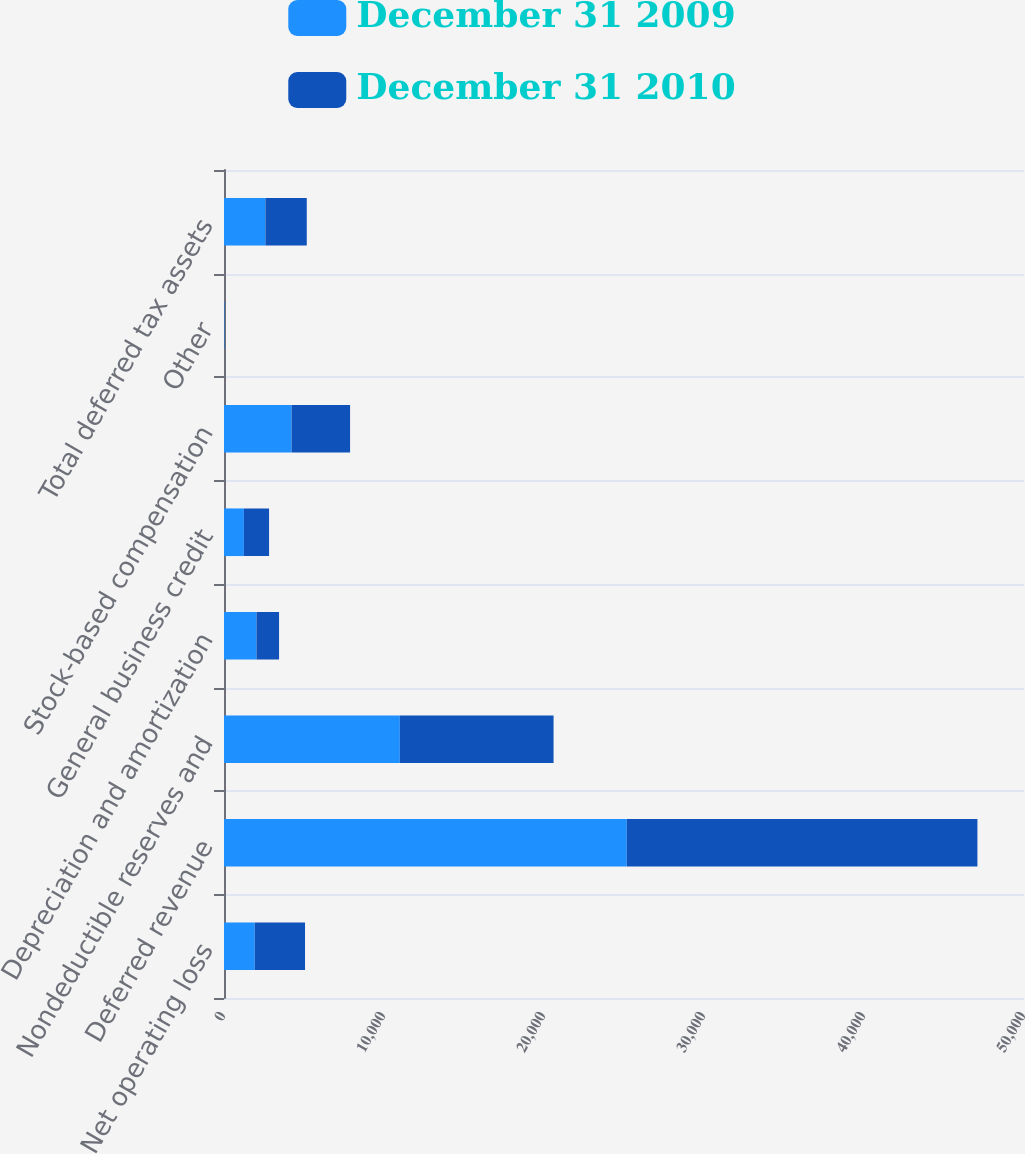Convert chart. <chart><loc_0><loc_0><loc_500><loc_500><stacked_bar_chart><ecel><fcel>Net operating loss<fcel>Deferred revenue<fcel>Nondeductible reserves and<fcel>Depreciation and amortization<fcel>General business credit<fcel>Stock-based compensation<fcel>Other<fcel>Total deferred tax assets<nl><fcel>December 31 2009<fcel>1920<fcel>25173<fcel>10990<fcel>2029<fcel>1243<fcel>4225<fcel>21<fcel>2586.5<nl><fcel>December 31 2010<fcel>3144<fcel>21915<fcel>9607<fcel>1412<fcel>1574<fcel>3655<fcel>16<fcel>2586.5<nl></chart> 